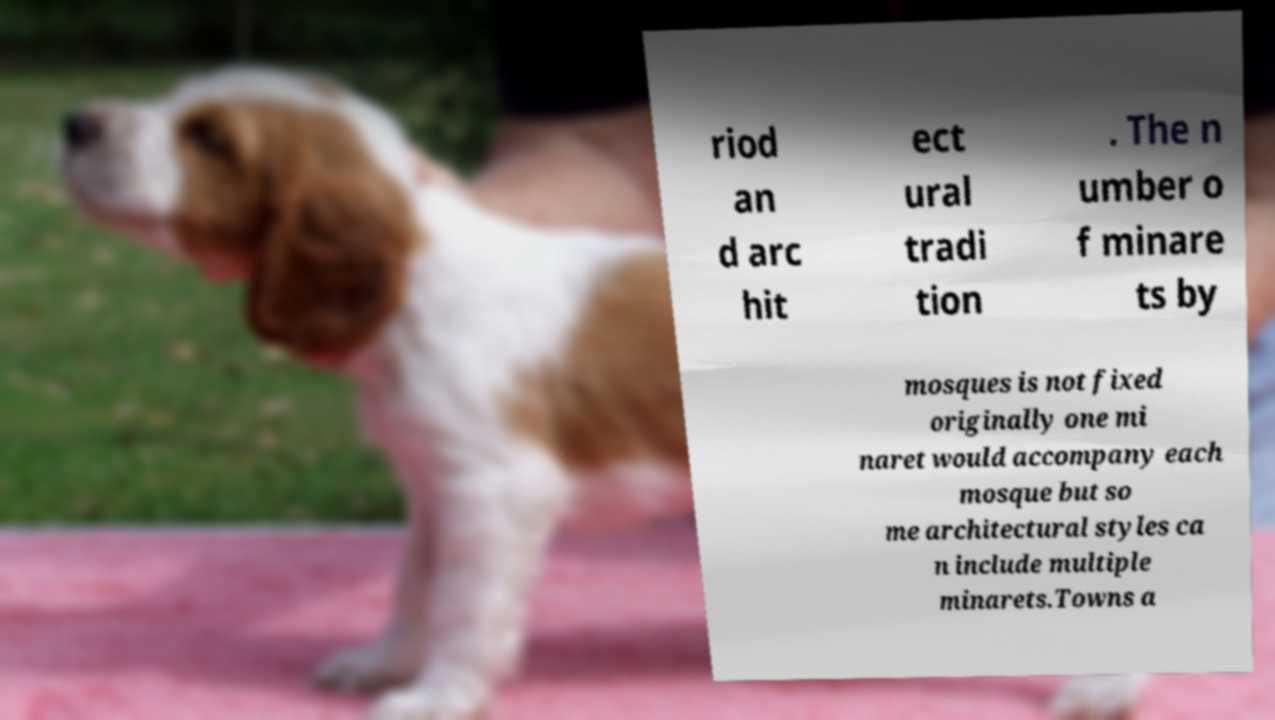Could you assist in decoding the text presented in this image and type it out clearly? riod an d arc hit ect ural tradi tion . The n umber o f minare ts by mosques is not fixed originally one mi naret would accompany each mosque but so me architectural styles ca n include multiple minarets.Towns a 